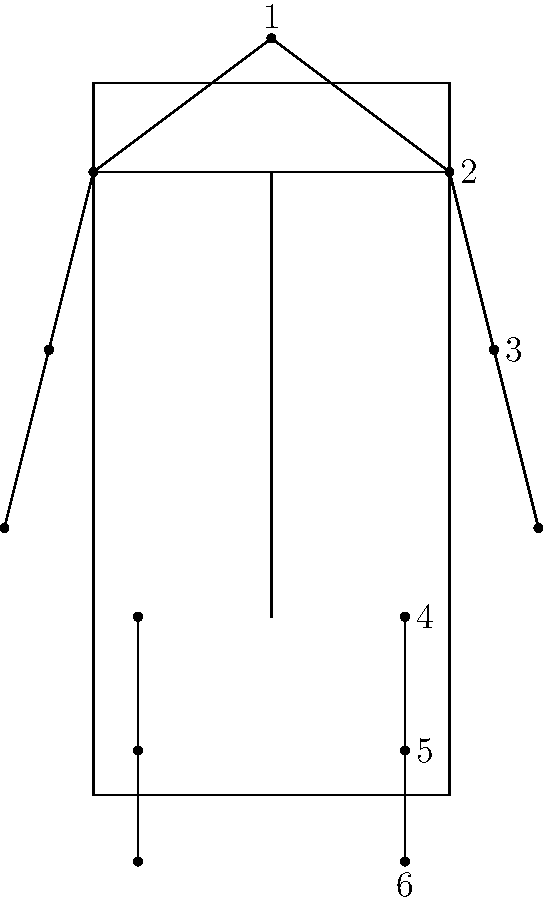Based on the body diagram, which numbered area typically takes the longest to heal from a severe injury in rugby, and approximately how long does the recovery process usually take? To answer this question, we need to consider the common severe injuries in rugby and their typical healing times:

1. Head (1): Concussions can vary in severity, but typically resolve within 7-10 days for most athletes.
2. Shoulder (2): Dislocations or rotator cuff injuries can take 3-6 months for full recovery.
3. Elbow (3): Fractures or ligament injuries may require 6-12 weeks of healing.
4. Hip (4): Severe strains or labral tears might need 3-4 months of rehabilitation.
5. Knee (5): ACL or MCL tears are common in rugby and typically require 6-9 months for full recovery and return to play.
6. Foot/Ankle (6): Severe sprains or fractures usually heal within 6-12 weeks.

Among these injuries, knee injuries (5) tend to have the longest recovery time, particularly ACL tears, which are unfortunately common in rugby due to the sport's physical nature and frequent changes in direction.

The recovery process for a severe knee injury like an ACL tear typically involves:
1. Initial rest and swelling reduction (1-2 weeks)
2. Surgery (if necessary)
3. Post-surgery recovery (2-6 weeks)
4. Physical therapy and gradual strength building (3-4 months)
5. Sport-specific training and conditioning (2-3 months)
6. Return to play protocol (1-2 months)

This entire process usually takes 6-9 months for a full return to competitive play, making it the longest recovery among common rugby injuries.
Answer: Knee (5), 6-9 months 